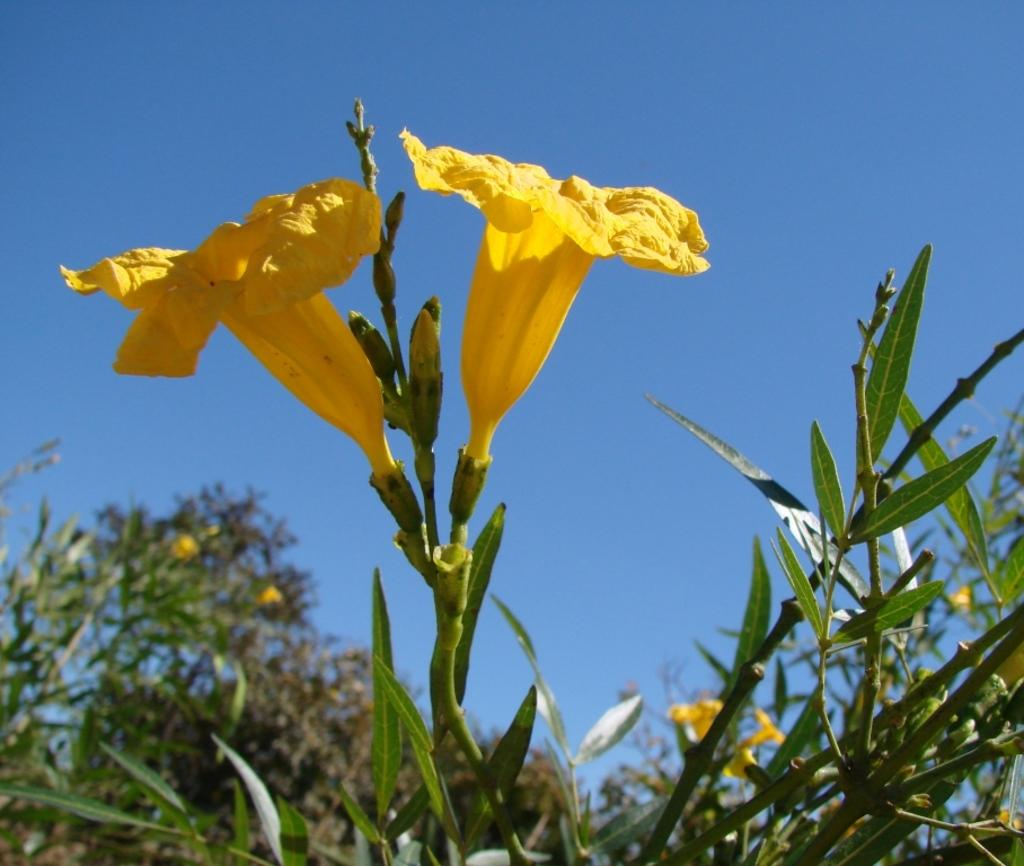What type of living organisms can be seen in the image? There are flowers and plants visible in the image. What stage of growth can be observed in the image? There are buds in the image, indicating that some of the plants are in the early stages of growth. What is visible in the background of the image? The sky is visible in the background of the image. What type of thumb can be seen in the image? There is no thumb present in the image. Is the image depicting a winter scene? The image does not provide any information about the season, so it cannot be determined if it is a winter scene. 